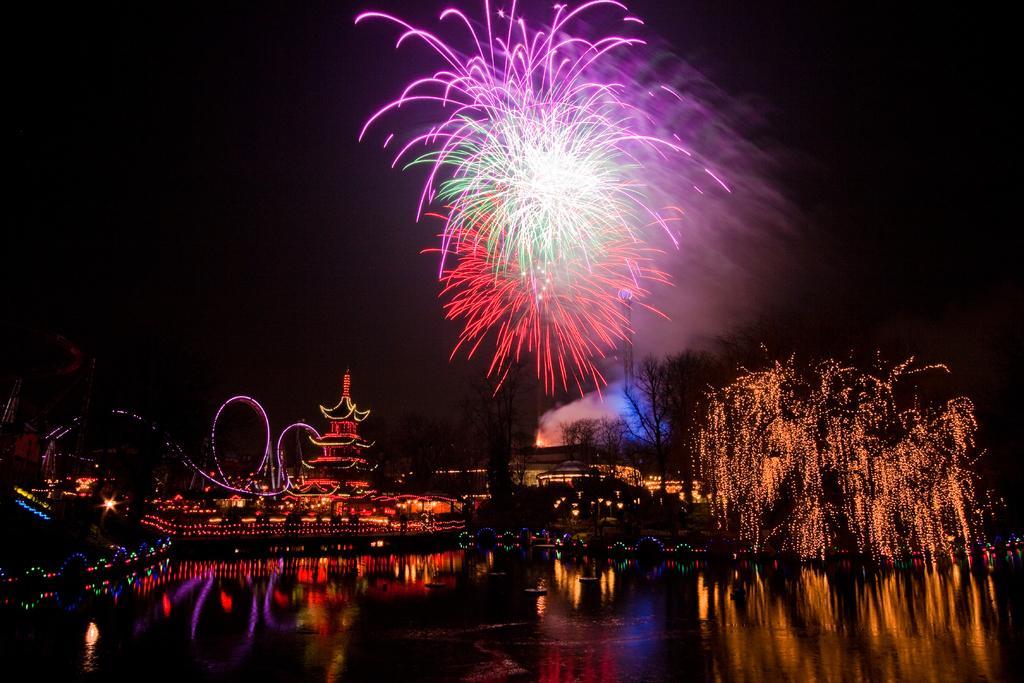Describe this image in one or two sentences. This is the picture of a city. In this image there is a boat on the water. At the back there are buildings and trees. At the top there is sky and there are crackers in the sky. At the bottom there is water. There are lights on the trees and buildings. 